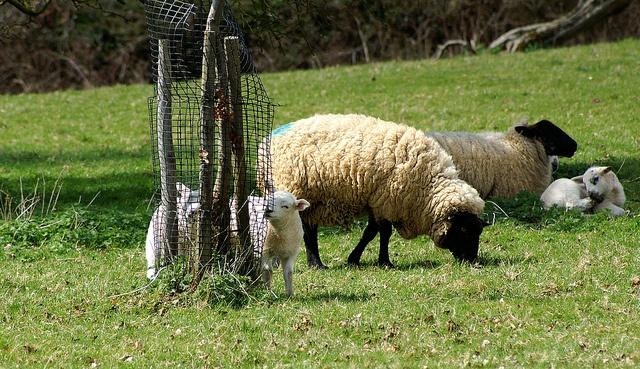Describe the objects in this image and their specific colors. I can see sheep in black, beige, tan, and olive tones, sheep in black, olive, and gray tones, sheep in black, darkgray, gray, and lightgray tones, sheep in black, gray, darkgreen, and darkgray tones, and sheep in black, white, darkgray, and gray tones in this image. 